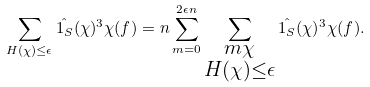<formula> <loc_0><loc_0><loc_500><loc_500>\sum _ { H ( \chi ) \leq \epsilon } \hat { 1 _ { S } } ( \chi ) ^ { 3 } \chi ( f ) = n \sum _ { m = 0 } ^ { 2 \epsilon n } \sum _ { \substack { m \chi \\ H ( \chi ) \leq \epsilon } } \hat { 1 _ { S } } ( \chi ) ^ { 3 } \chi ( f ) .</formula> 